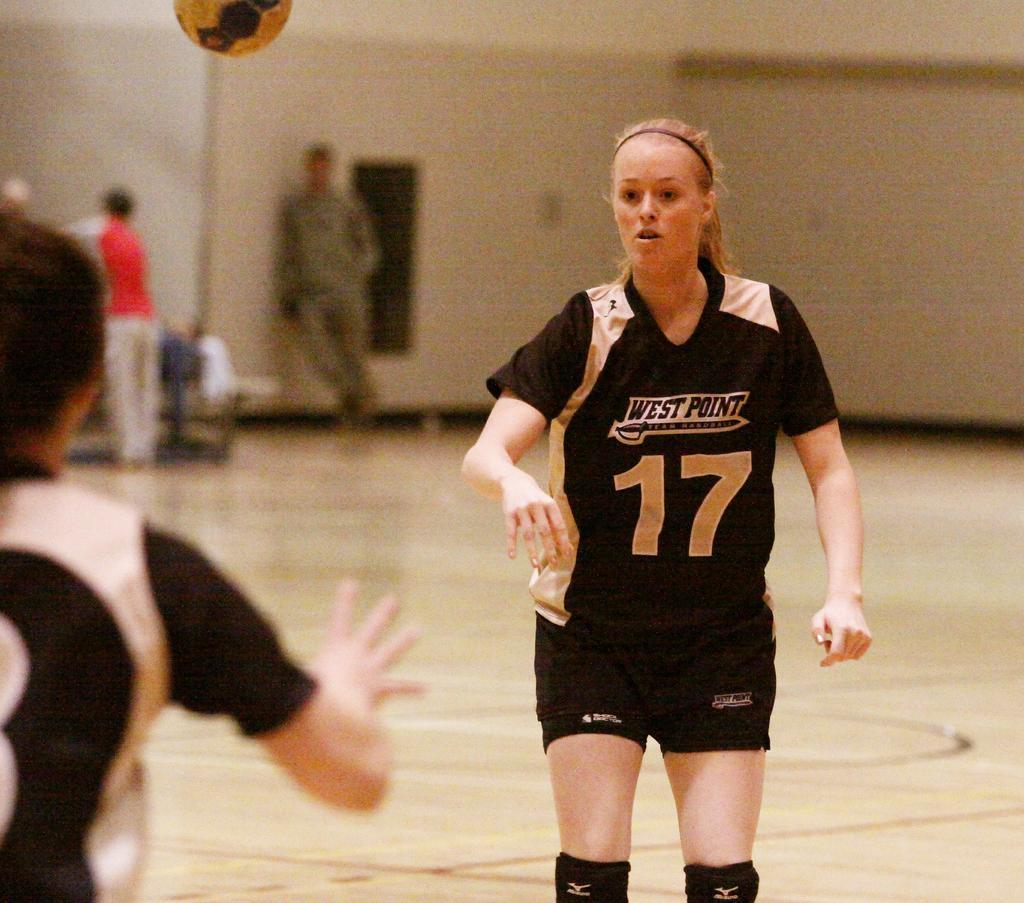Can you describe this image briefly? In this image in the foreground there is one woman who is standing, and it seems that she is playing something and on the left side there is another person and there is one ball at the top. In the background there are some people and wall and objects, at the bottom there is floor. 